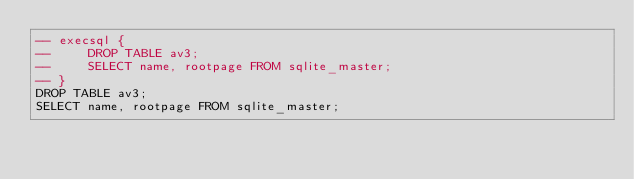Convert code to text. <code><loc_0><loc_0><loc_500><loc_500><_SQL_>-- execsql {
--     DROP TABLE av3;
--     SELECT name, rootpage FROM sqlite_master;
-- }
DROP TABLE av3;
SELECT name, rootpage FROM sqlite_master;</code> 